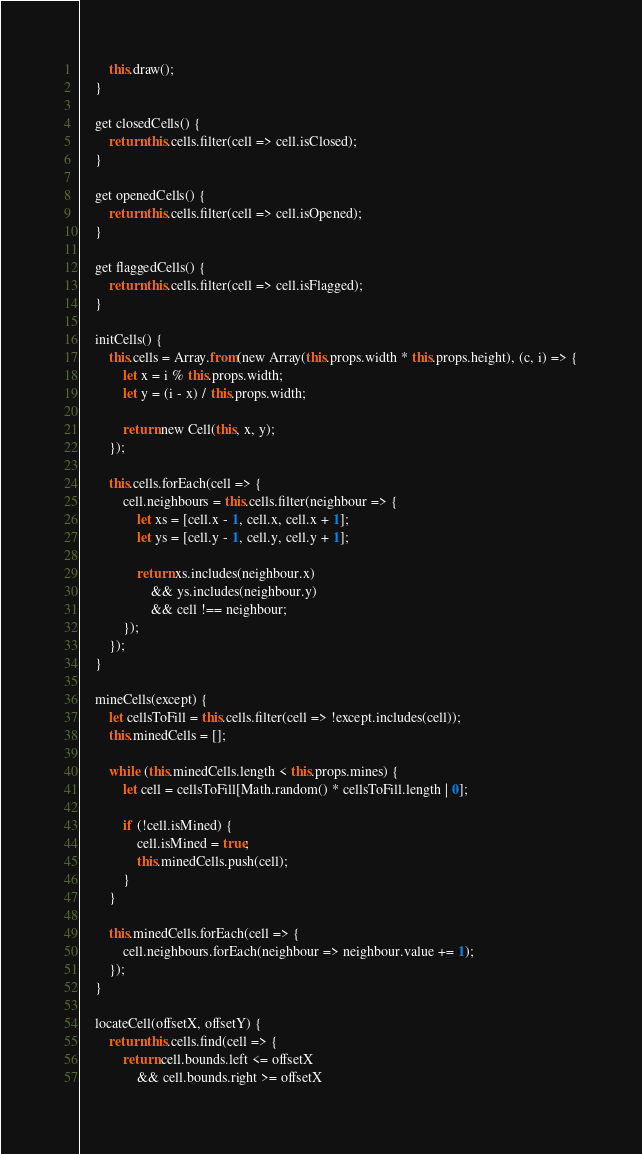<code> <loc_0><loc_0><loc_500><loc_500><_JavaScript_>
        this.draw();
    }

    get closedCells() {
        return this.cells.filter(cell => cell.isClosed);
    }

    get openedCells() {
        return this.cells.filter(cell => cell.isOpened);
    }

    get flaggedCells() {
        return this.cells.filter(cell => cell.isFlagged);
    }

    initCells() {
        this.cells = Array.from(new Array(this.props.width * this.props.height), (c, i) => {
            let x = i % this.props.width;
            let y = (i - x) / this.props.width;

            return new Cell(this, x, y);
        });

        this.cells.forEach(cell => {
            cell.neighbours = this.cells.filter(neighbour => {
                let xs = [cell.x - 1, cell.x, cell.x + 1];
                let ys = [cell.y - 1, cell.y, cell.y + 1];

                return xs.includes(neighbour.x)
                    && ys.includes(neighbour.y)
                    && cell !== neighbour;
            });
        });
    }

    mineCells(except) {
        let cellsToFill = this.cells.filter(cell => !except.includes(cell));
        this.minedCells = [];

        while (this.minedCells.length < this.props.mines) {
            let cell = cellsToFill[Math.random() * cellsToFill.length | 0];

            if (!cell.isMined) {
                cell.isMined = true;
                this.minedCells.push(cell);
            }
        }

        this.minedCells.forEach(cell => {
            cell.neighbours.forEach(neighbour => neighbour.value += 1);
        });
    }

    locateCell(offsetX, offsetY) {
        return this.cells.find(cell => {
            return cell.bounds.left <= offsetX
                && cell.bounds.right >= offsetX</code> 